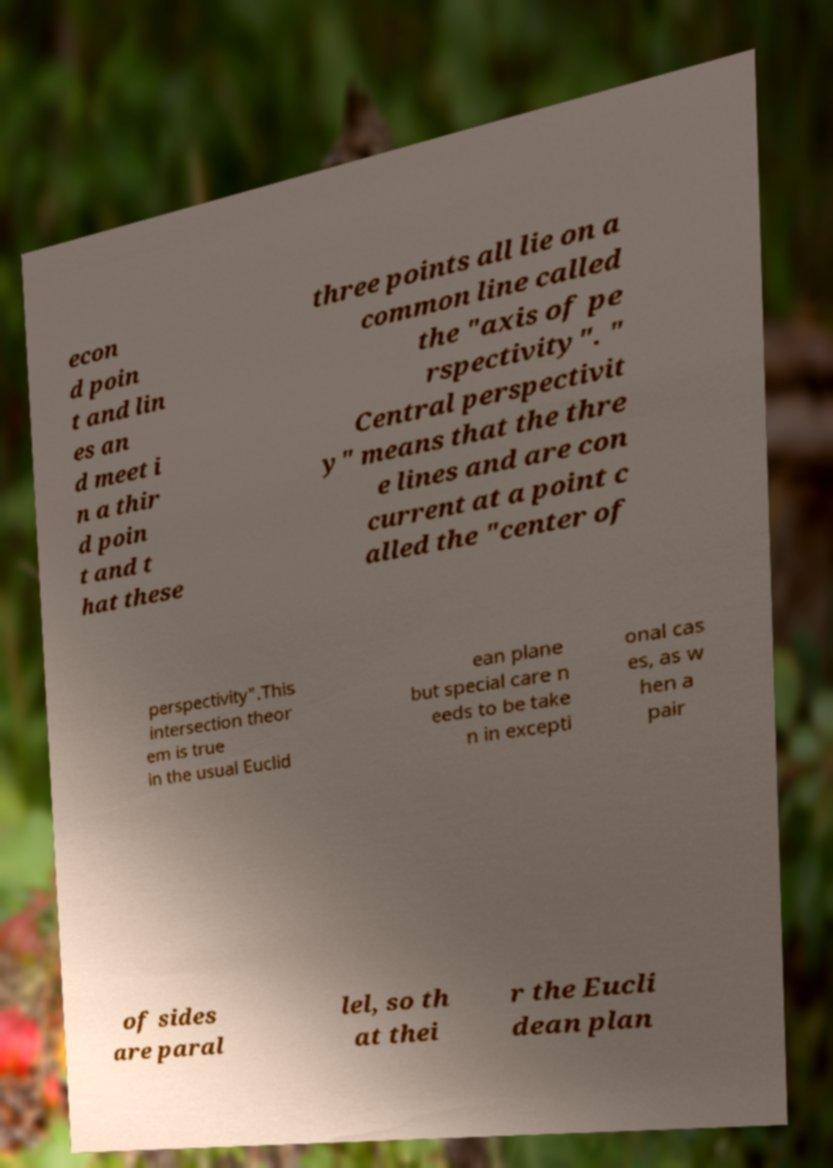For documentation purposes, I need the text within this image transcribed. Could you provide that? econ d poin t and lin es an d meet i n a thir d poin t and t hat these three points all lie on a common line called the "axis of pe rspectivity". " Central perspectivit y" means that the thre e lines and are con current at a point c alled the "center of perspectivity".This intersection theor em is true in the usual Euclid ean plane but special care n eeds to be take n in excepti onal cas es, as w hen a pair of sides are paral lel, so th at thei r the Eucli dean plan 